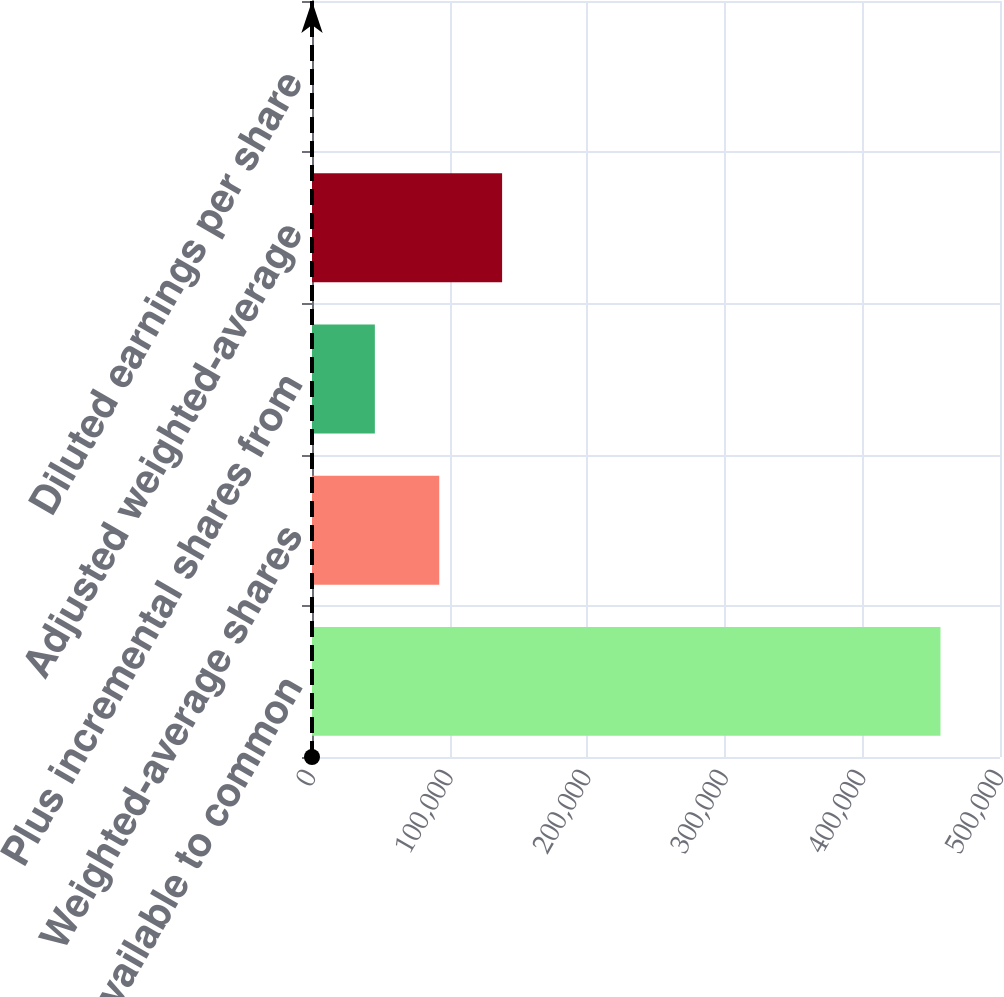Convert chart. <chart><loc_0><loc_0><loc_500><loc_500><bar_chart><fcel>Income available to common<fcel>Weighted-average shares<fcel>Plus incremental shares from<fcel>Adjusted weighted-average<fcel>Diluted earnings per share<nl><fcel>456752<fcel>92483<fcel>45679.5<fcel>138158<fcel>4.78<nl></chart> 